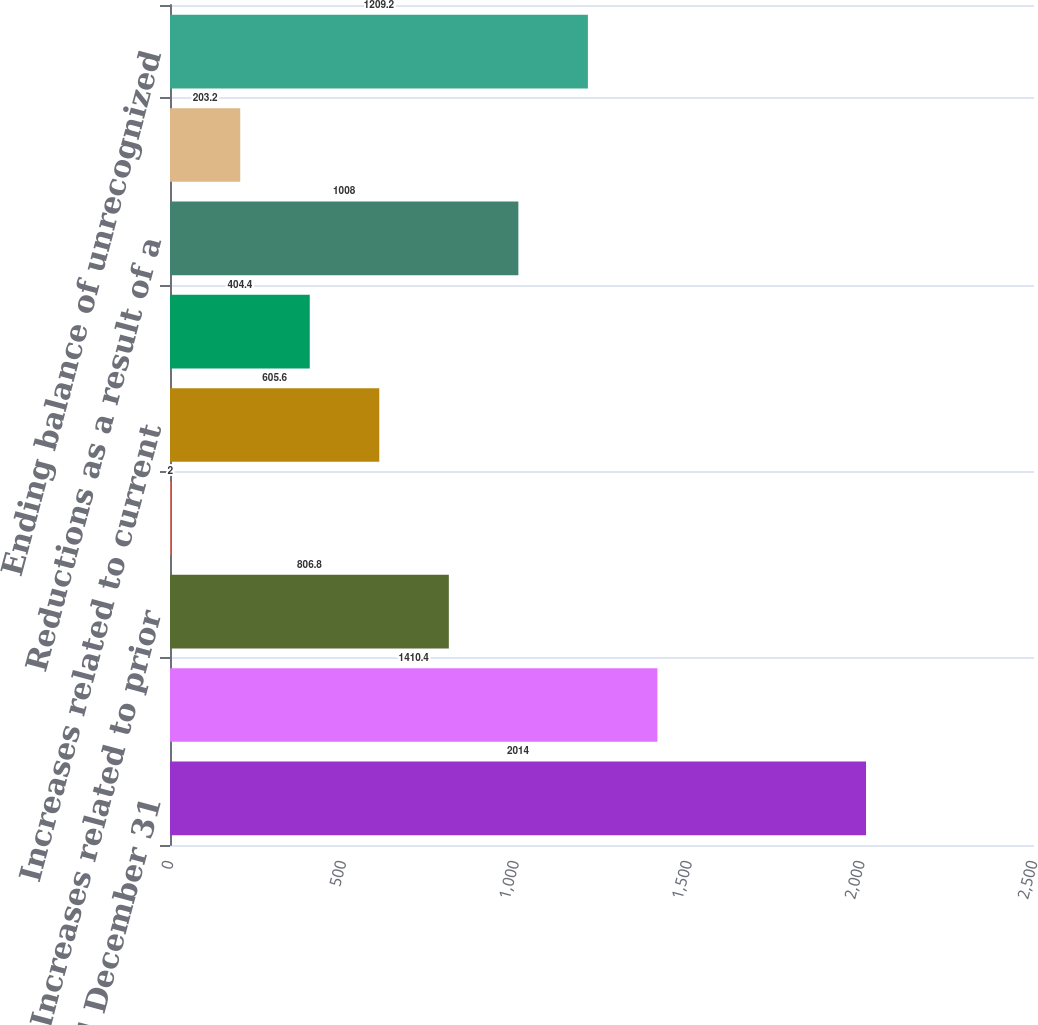Convert chart. <chart><loc_0><loc_0><loc_500><loc_500><bar_chart><fcel>Year Ended December 31<fcel>Beginning balance of<fcel>Increases related to prior<fcel>Decreases related to prior<fcel>Increases related to current<fcel>Decreases related to<fcel>Reductions as a result of a<fcel>Increases (decreases) from<fcel>Ending balance of unrecognized<nl><fcel>2014<fcel>1410.4<fcel>806.8<fcel>2<fcel>605.6<fcel>404.4<fcel>1008<fcel>203.2<fcel>1209.2<nl></chart> 